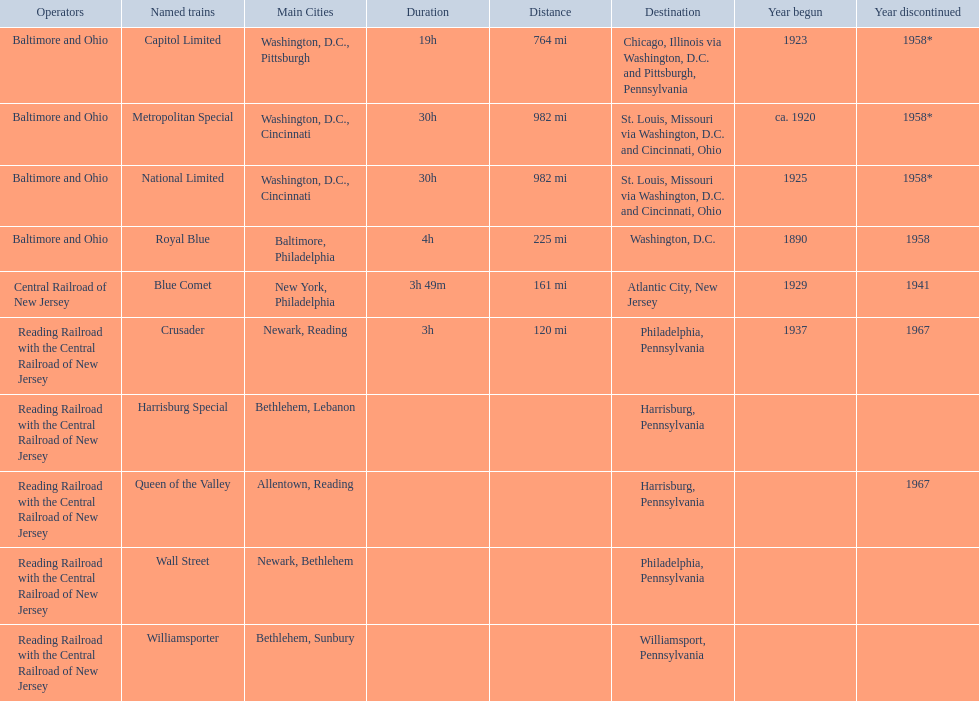What destinations are there? Chicago, Illinois via Washington, D.C. and Pittsburgh, Pennsylvania, St. Louis, Missouri via Washington, D.C. and Cincinnati, Ohio, St. Louis, Missouri via Washington, D.C. and Cincinnati, Ohio, Washington, D.C., Atlantic City, New Jersey, Philadelphia, Pennsylvania, Harrisburg, Pennsylvania, Harrisburg, Pennsylvania, Philadelphia, Pennsylvania, Williamsport, Pennsylvania. Which one is at the top of the list? Chicago, Illinois via Washington, D.C. and Pittsburgh, Pennsylvania. 